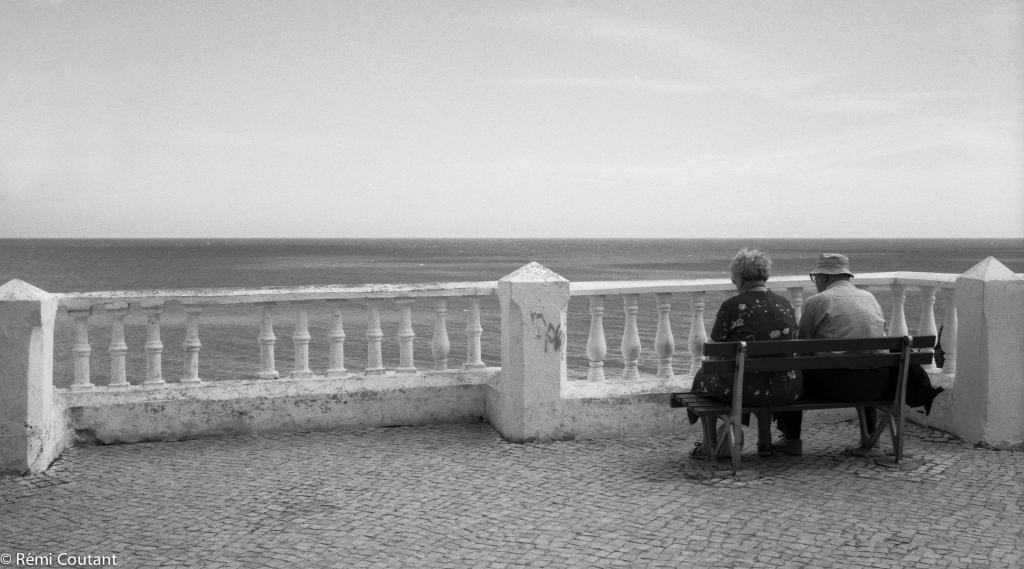Who is present in the image? There is a lady and a man wearing a hat in the image. What are the man and lady doing in the image? The man and lady are sitting on a bench in the image. What can be seen near the bench in the image? There are railings visible in the image. What is visible in the background of the image? Sky and water are visible in the background of the image. Where is the hydrant located in the image? There is no hydrant present in the image. Who is the friend of the lady in the image? The provided facts do not mention any friends or relationships between the man and lady in the image. --- Facts: 1. There is a car in the image. 2. The car is red. 3. The car has four wheels. 4. There is a road in the image. 5. The road is paved. Absurd Topics: bird, ocean, mountain Conversation: What is the main subject of the image? The main subject of the image is a car. What color is the car? The car is red. How many wheels does the car have? The car has four wheels. What type of surface is the car on in the image? There is a road in the image, and it is paved. Reasoning: Let's think step by step by step in order to produce the conversation. We start by identifying the main subject of the image, which is the car. Then, we describe the car's color and the number of wheels it has. Next, we mention the presence of a road in the image and describe its surface as paved. Absurd Question/Answer: Can you see any birds flying over the ocean in the image? There is no ocean or birds present in the image; it features a red car on a paved road. What type of mountain range can be seen in the background of the image? There is no mountain range visible in the image; it only shows a red car on a paved road. 